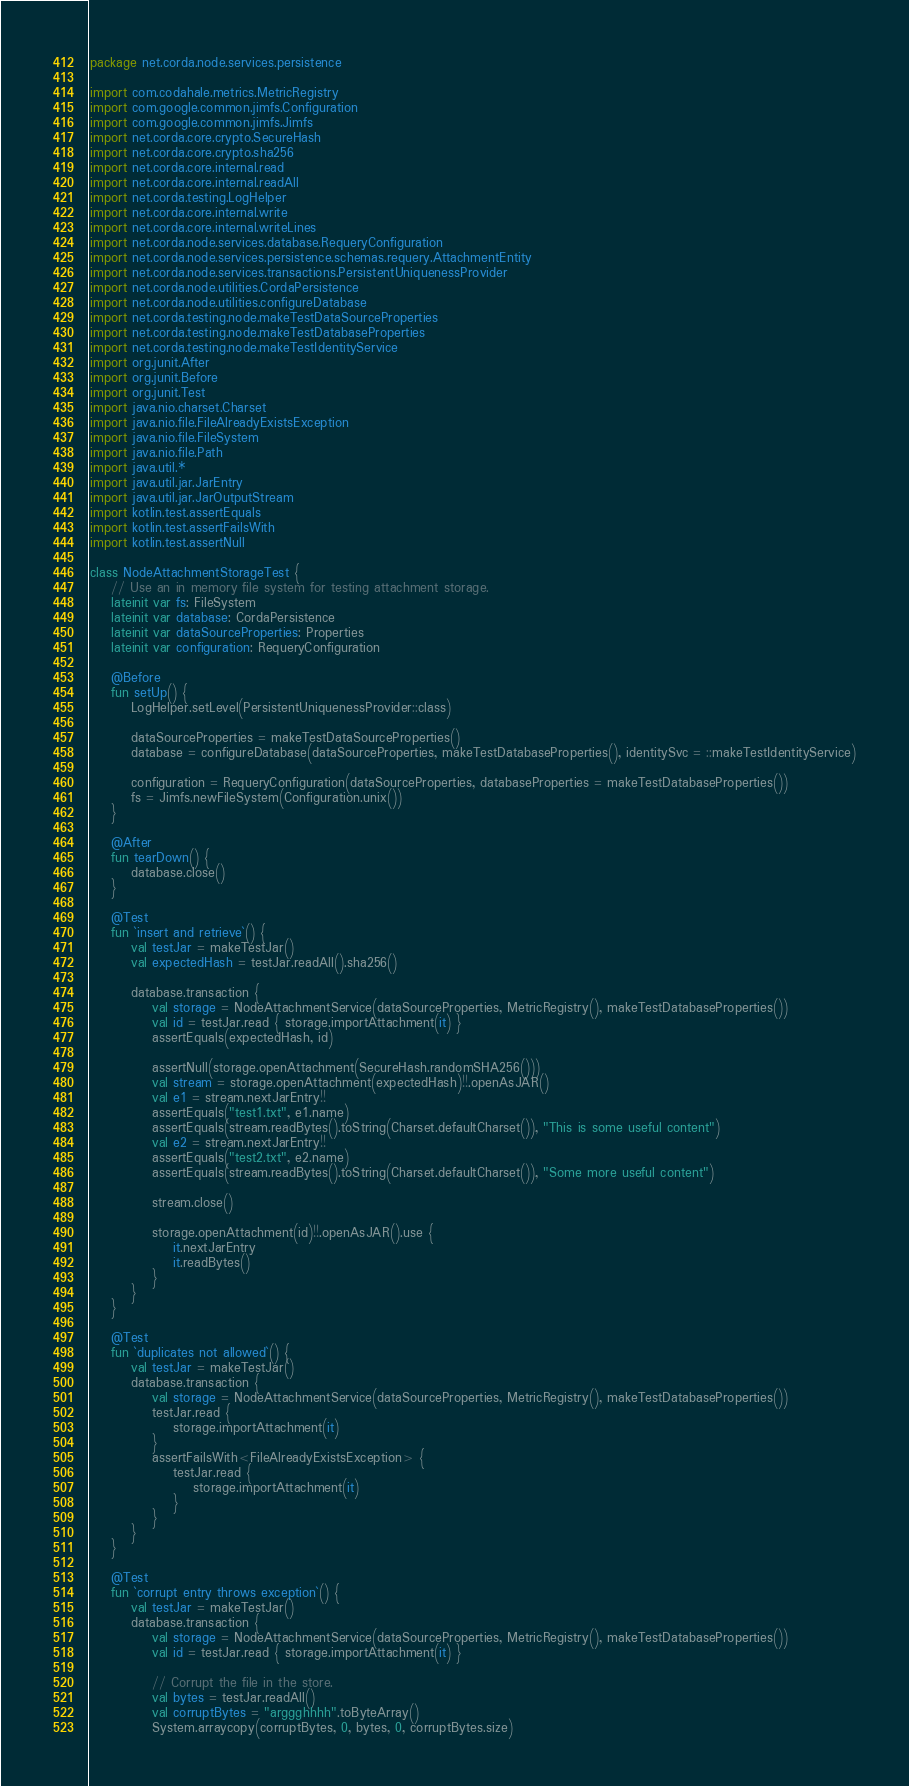Convert code to text. <code><loc_0><loc_0><loc_500><loc_500><_Kotlin_>package net.corda.node.services.persistence

import com.codahale.metrics.MetricRegistry
import com.google.common.jimfs.Configuration
import com.google.common.jimfs.Jimfs
import net.corda.core.crypto.SecureHash
import net.corda.core.crypto.sha256
import net.corda.core.internal.read
import net.corda.core.internal.readAll
import net.corda.testing.LogHelper
import net.corda.core.internal.write
import net.corda.core.internal.writeLines
import net.corda.node.services.database.RequeryConfiguration
import net.corda.node.services.persistence.schemas.requery.AttachmentEntity
import net.corda.node.services.transactions.PersistentUniquenessProvider
import net.corda.node.utilities.CordaPersistence
import net.corda.node.utilities.configureDatabase
import net.corda.testing.node.makeTestDataSourceProperties
import net.corda.testing.node.makeTestDatabaseProperties
import net.corda.testing.node.makeTestIdentityService
import org.junit.After
import org.junit.Before
import org.junit.Test
import java.nio.charset.Charset
import java.nio.file.FileAlreadyExistsException
import java.nio.file.FileSystem
import java.nio.file.Path
import java.util.*
import java.util.jar.JarEntry
import java.util.jar.JarOutputStream
import kotlin.test.assertEquals
import kotlin.test.assertFailsWith
import kotlin.test.assertNull

class NodeAttachmentStorageTest {
    // Use an in memory file system for testing attachment storage.
    lateinit var fs: FileSystem
    lateinit var database: CordaPersistence
    lateinit var dataSourceProperties: Properties
    lateinit var configuration: RequeryConfiguration

    @Before
    fun setUp() {
        LogHelper.setLevel(PersistentUniquenessProvider::class)

        dataSourceProperties = makeTestDataSourceProperties()
        database = configureDatabase(dataSourceProperties, makeTestDatabaseProperties(), identitySvc = ::makeTestIdentityService)

        configuration = RequeryConfiguration(dataSourceProperties, databaseProperties = makeTestDatabaseProperties())
        fs = Jimfs.newFileSystem(Configuration.unix())
    }

    @After
    fun tearDown() {
        database.close()
    }

    @Test
    fun `insert and retrieve`() {
        val testJar = makeTestJar()
        val expectedHash = testJar.readAll().sha256()

        database.transaction {
            val storage = NodeAttachmentService(dataSourceProperties, MetricRegistry(), makeTestDatabaseProperties())
            val id = testJar.read { storage.importAttachment(it) }
            assertEquals(expectedHash, id)

            assertNull(storage.openAttachment(SecureHash.randomSHA256()))
            val stream = storage.openAttachment(expectedHash)!!.openAsJAR()
            val e1 = stream.nextJarEntry!!
            assertEquals("test1.txt", e1.name)
            assertEquals(stream.readBytes().toString(Charset.defaultCharset()), "This is some useful content")
            val e2 = stream.nextJarEntry!!
            assertEquals("test2.txt", e2.name)
            assertEquals(stream.readBytes().toString(Charset.defaultCharset()), "Some more useful content")

            stream.close()

            storage.openAttachment(id)!!.openAsJAR().use {
                it.nextJarEntry
                it.readBytes()
            }
        }
    }

    @Test
    fun `duplicates not allowed`() {
        val testJar = makeTestJar()
        database.transaction {
            val storage = NodeAttachmentService(dataSourceProperties, MetricRegistry(), makeTestDatabaseProperties())
            testJar.read {
                storage.importAttachment(it)
            }
            assertFailsWith<FileAlreadyExistsException> {
                testJar.read {
                    storage.importAttachment(it)
                }
            }
        }
    }

    @Test
    fun `corrupt entry throws exception`() {
        val testJar = makeTestJar()
        database.transaction {
            val storage = NodeAttachmentService(dataSourceProperties, MetricRegistry(), makeTestDatabaseProperties())
            val id = testJar.read { storage.importAttachment(it) }

            // Corrupt the file in the store.
            val bytes = testJar.readAll()
            val corruptBytes = "arggghhhh".toByteArray()
            System.arraycopy(corruptBytes, 0, bytes, 0, corruptBytes.size)</code> 